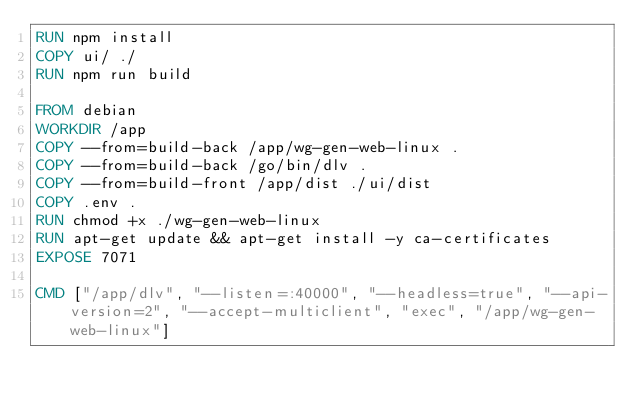Convert code to text. <code><loc_0><loc_0><loc_500><loc_500><_Dockerfile_>RUN npm install
COPY ui/ ./
RUN npm run build

FROM debian
WORKDIR /app
COPY --from=build-back /app/wg-gen-web-linux .
COPY --from=build-back /go/bin/dlv .
COPY --from=build-front /app/dist ./ui/dist
COPY .env .
RUN chmod +x ./wg-gen-web-linux
RUN apt-get update && apt-get install -y ca-certificates
EXPOSE 7071

CMD ["/app/dlv", "--listen=:40000", "--headless=true", "--api-version=2", "--accept-multiclient", "exec", "/app/wg-gen-web-linux"]</code> 